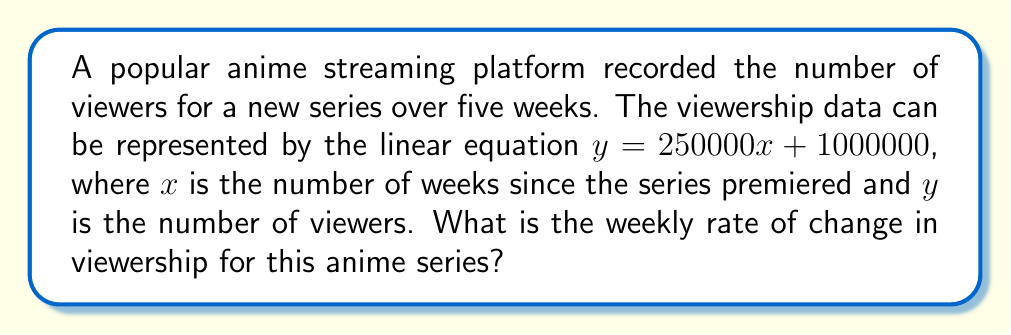Teach me how to tackle this problem. To determine the rate of change in anime viewership over time, we need to analyze the given linear equation:

$y = 250000x + 1000000$

In a linear equation of the form $y = mx + b$:
- $m$ represents the slope of the line, which is the rate of change
- $b$ represents the y-intercept

In our equation:
$y = 250000x + 1000000$

We can identify that:
$m = 250000$
$b = 1000000$

The slope $m = 250000$ represents the rate of change in viewership per week. This means that for each week that passes (for each unit increase in $x$), the number of viewers ($y$) increases by 250,000.

Therefore, the weekly rate of change in viewership for this anime series is 250,000 viewers per week.
Answer: 250,000 viewers/week 